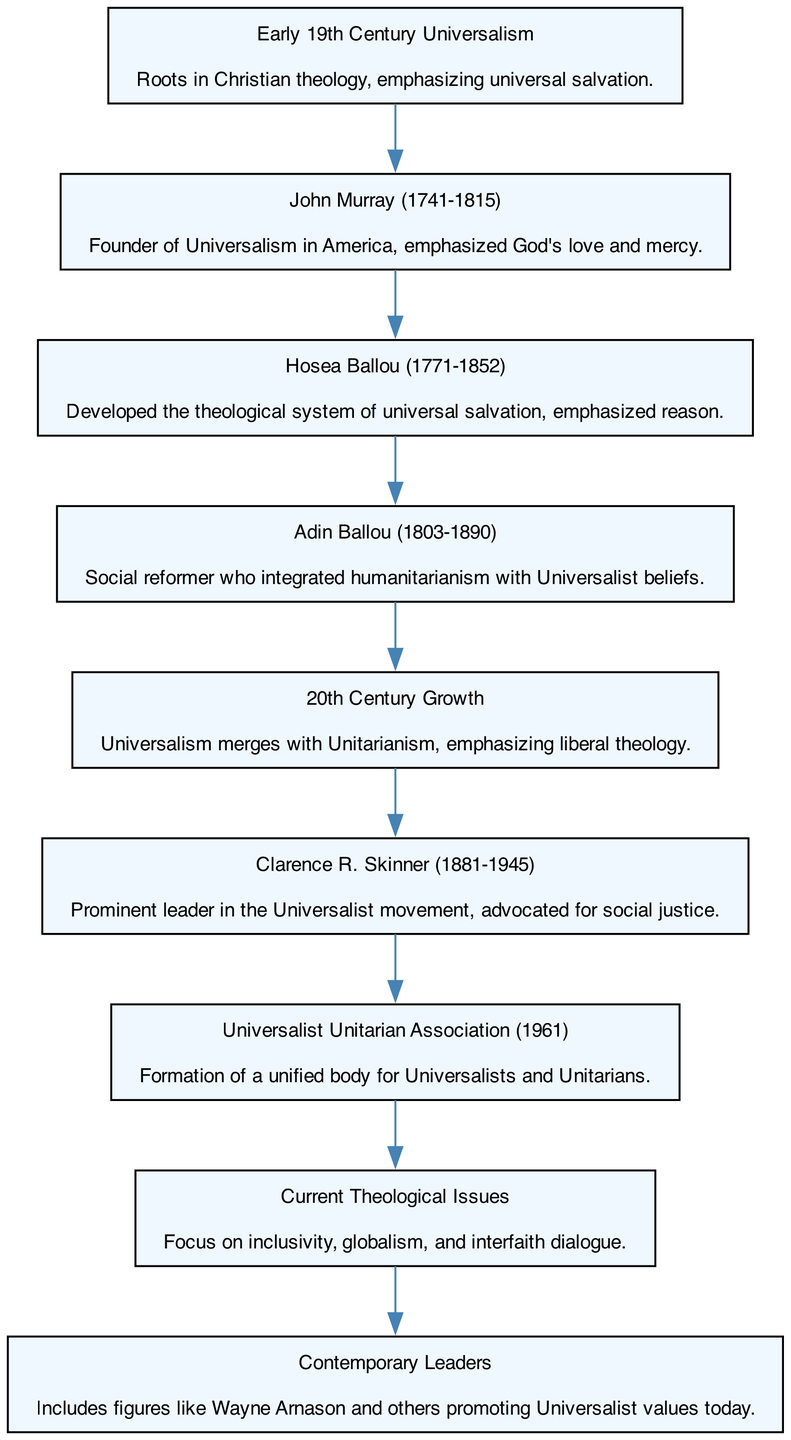What is the starting point of the flow chart? The flow chart begins with the node titled "Early 19th Century Universalism." This is the first element listed, and it denotes the foundation of Universalist theology.
Answer: Early 19th Century Universalism Who is identified as the founder of Universalism in America? The node for John Murray directly follows "Early 19th Century Universalism," stating he is the founder. This context indicates his central role in establishing Universalism in the United States.
Answer: John Murray Which key leader emphasized reason in their theological contributions? The following node after John Murray is Hosea Ballou, which describes his development of a theological system of universal salvation with an emphasis on reason, indicating his reasoning approach to theology.
Answer: Hosea Ballou What significant event occurred in 1961 within Universalist history? The diagram marks the "Universalist Unitarian Association (1961)" as a node, which indicates the formation of a unified body for Universalists and Unitarians, highlighting a critical point in the evolution of Universalist theology.
Answer: Formation How many leaders are prominently mentioned in the flow chart? The flow chart lists six notable figures, each identified as contributing leaders: John Murray, Hosea Ballou, Adin Ballou, Clarence R. Skinner, and contemporary leaders. Counting these distinct points gives us the total number.
Answer: Six What is the primary focus of Current Theological Issues depicted in the chart? The node labeled "Current Theological Issues" indicates a focus on themes like inclusivity, globalism, and interfaith dialogue, suggesting modern themes within Universalism that reflect on its current values and challenges.
Answer: Inclusivity Which leader advocated for social justice? The node for Clarence R. Skinner describes him as a prominent leader advocating for social justice, showcasing his significant contribution to the Universalist movement.
Answer: Clarence R. Skinner How does the flow chart represent the transition to the 20th century? The node labeled "20th Century Growth" follows "Hosea Ballou" and indicates the merging of Universalism with Unitarianism and the emphasis on liberal theology, demonstrating a historical shift in the movement's focus.
Answer: Merges What is a key characteristic of Contemporary Leaders mentioned in the diagram? The flow chart states that Contemporary Leaders include figures like Wayne Arnason who promote Universalist values today, suggesting that these leaders reflect current ideals and practices within the Universalist tradition.
Answer: Promote Universalist values 